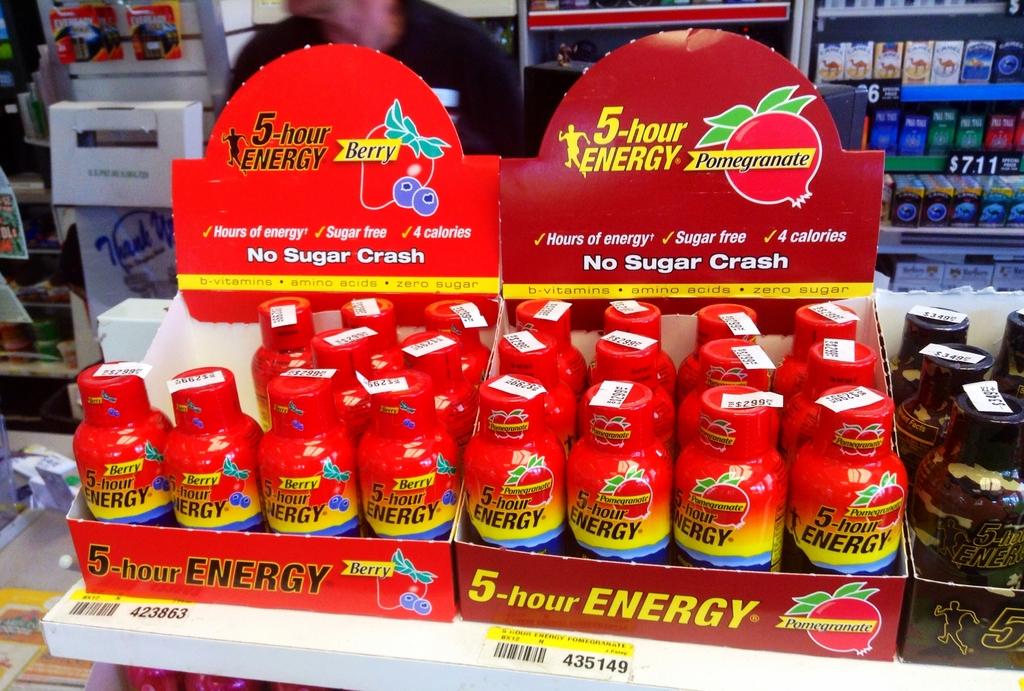What is the product name?
Provide a succinct answer. 5-hour energy. Who makes 5-hour energy drink?
Your response must be concise. 5-hour energy. 